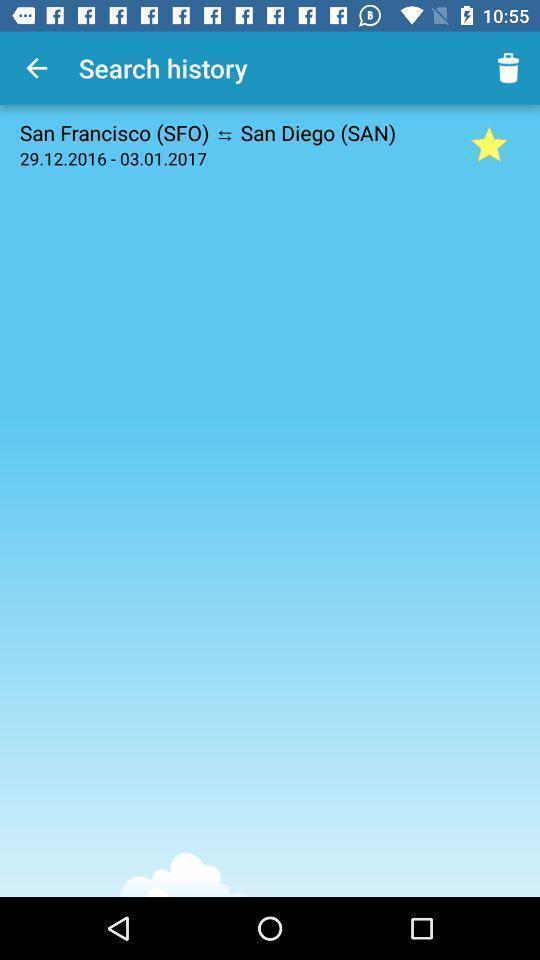Give me a summary of this screen capture. Search page to find history. 